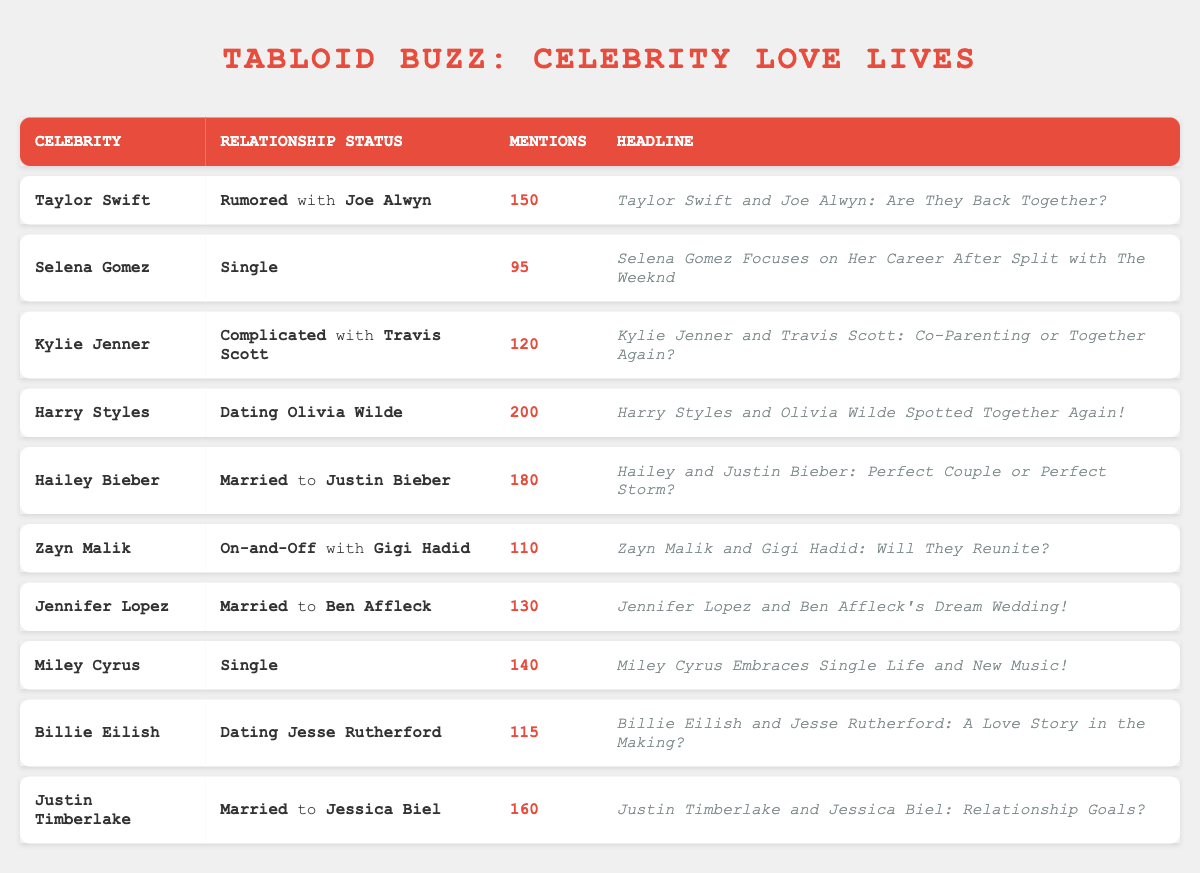What is the relationship status of Taylor Swift? The table shows that Taylor Swift's relationship status is "Rumored with Joe Alwyn."
Answer: Rumored with Joe Alwyn Which celebrity has the highest mentions in the table? By checking the "Mentions" column, Harry Styles is noted with 200 mentions, which is the highest among all listed celebrities.
Answer: Harry Styles How many celebrities are currently single according to the table? The table lists Selena Gomez and Miley Cyrus as single. Thus, there are two celebrities who are currently single.
Answer: 2 What is the total number of mentions for married couples in the table? The married couples mentioned are Hailey Bieber (180 mentions), Jennifer Lopez (130 mentions), and Justin Timberlake (160 mentions). Summing them yields 180 + 130 + 160 = 470.
Answer: 470 Is Billie Eilish's relationship status considered complicated? Billie Eilish's status is listed as "Dating Jesse Rutherford," which is not complicated. Thus, the statement is false.
Answer: No Which relationship has a higher mention count, Zayn Malik's or Selena Gomez's? Zayn Malik has 110 mentions while Selena Gomez has 95. Comparing the two shows that Zayn Malik has more mentions.
Answer: Zayn Malik What is the average number of mentions for celebrities in complicated relationships? Only Kylie Jenner (120 mentions) is in a complicated relationship. Since there's only one data point, the average is simply 120.
Answer: 120 What can be inferred about the relationship status of Justin Timberlake? The table indicates that Justin Timberlake is "Married to Jessica Biel," suggesting a stable relationship status.
Answer: Married to Jessica Biel How many mentions does Hailey Bieber have compared to Billie Eilish? Hailey Bieber has 180 mentions, while Billie Eilish has 115 mentions. The difference is calculated as 180 - 115 = 65.
Answer: 65 more mentions Are there any celebrities who are both rumored to be in a relationship and are married according to this table? The table shows Taylor Swift listed as "Rumored with Joe Alwyn" and other celebrities like Jennifer Lopez and Hailey Bieber who are married. This means there are no celebrities who fit both criteria.
Answer: No 